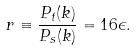<formula> <loc_0><loc_0><loc_500><loc_500>r \equiv \frac { P _ { t } ( k ) } { P _ { s } ( k ) } = 1 6 \epsilon .</formula> 